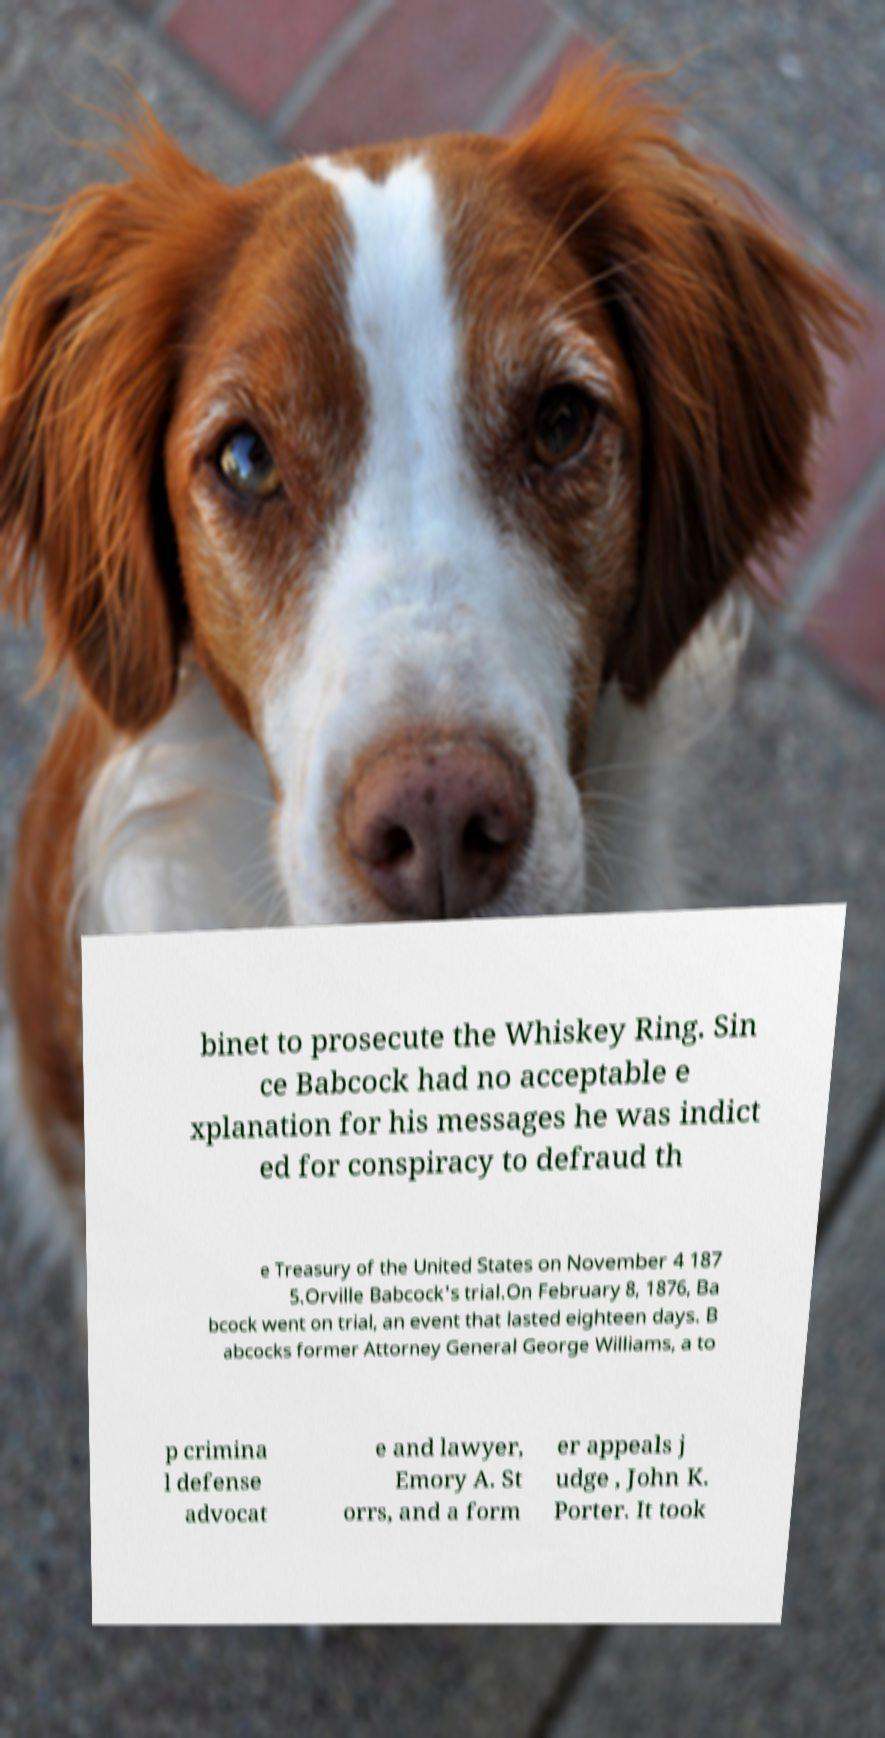Could you assist in decoding the text presented in this image and type it out clearly? binet to prosecute the Whiskey Ring. Sin ce Babcock had no acceptable e xplanation for his messages he was indict ed for conspiracy to defraud th e Treasury of the United States on November 4 187 5.Orville Babcock's trial.On February 8, 1876, Ba bcock went on trial, an event that lasted eighteen days. B abcocks former Attorney General George Williams, a to p crimina l defense advocat e and lawyer, Emory A. St orrs, and a form er appeals j udge , John K. Porter. It took 